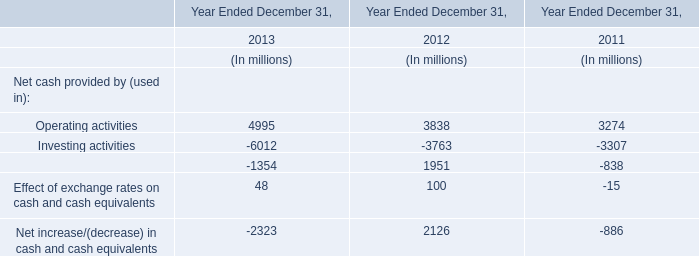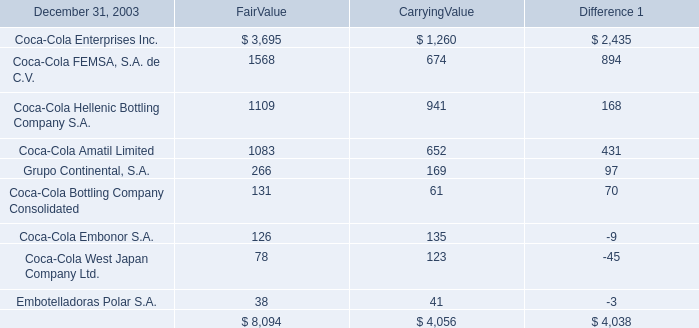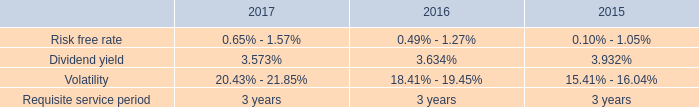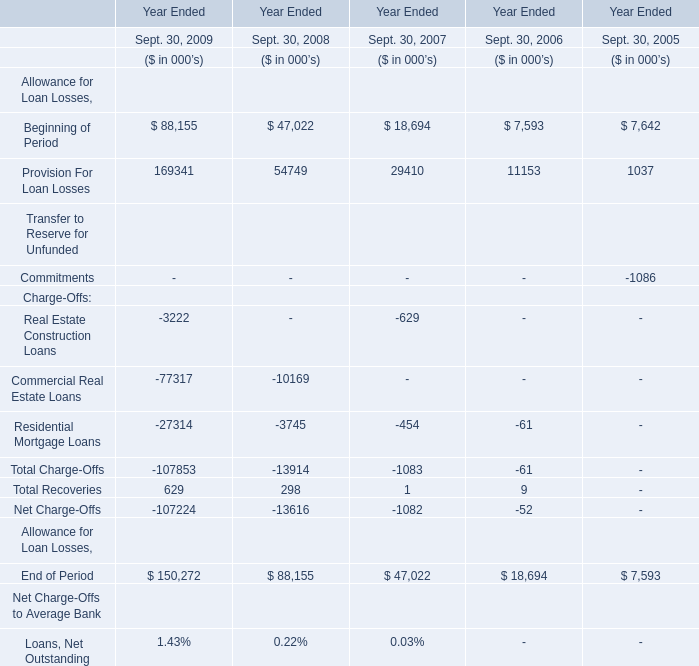considering the years 2015 and 2016 , what is the percentual increase observed in the total compensation expense under the stock plan? 
Computations: ((12.2 / 6.9) - 1)
Answer: 0.76812. 